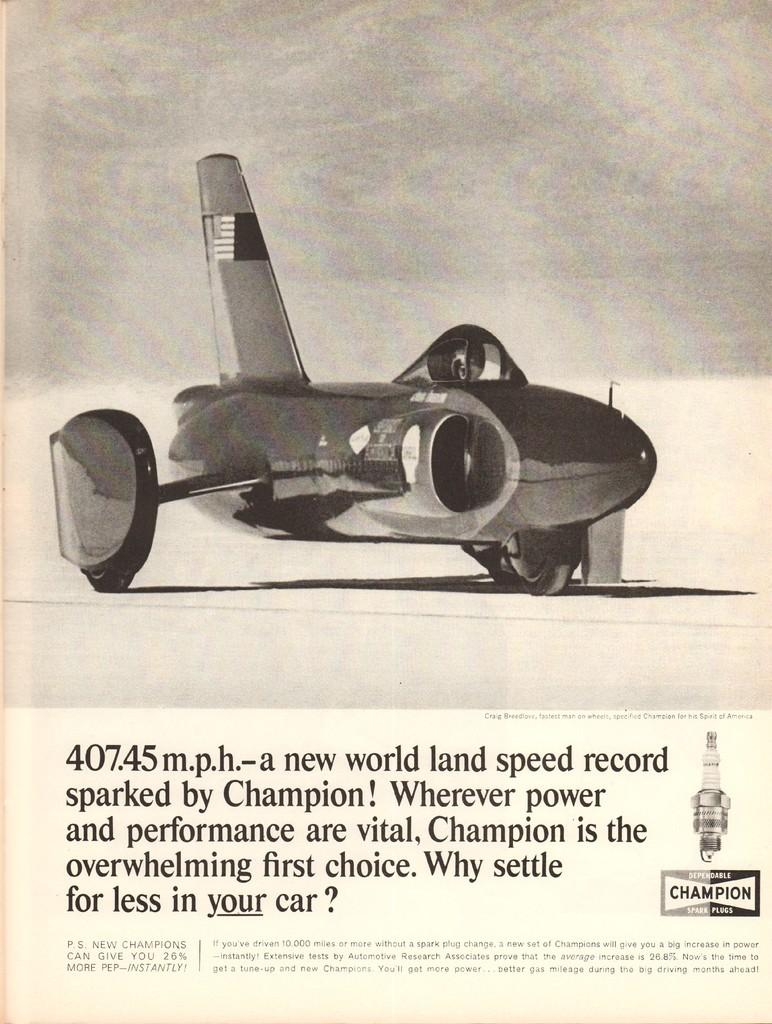What is the main subject of the page? The main subject of the page is an image of a plane. What type of information is provided below the image? There is some information mentioned below the image. Where is the nest of the plane located in the image? There is no nest mentioned or depicted in the image, as it features an image of a plane and accompanying information. 